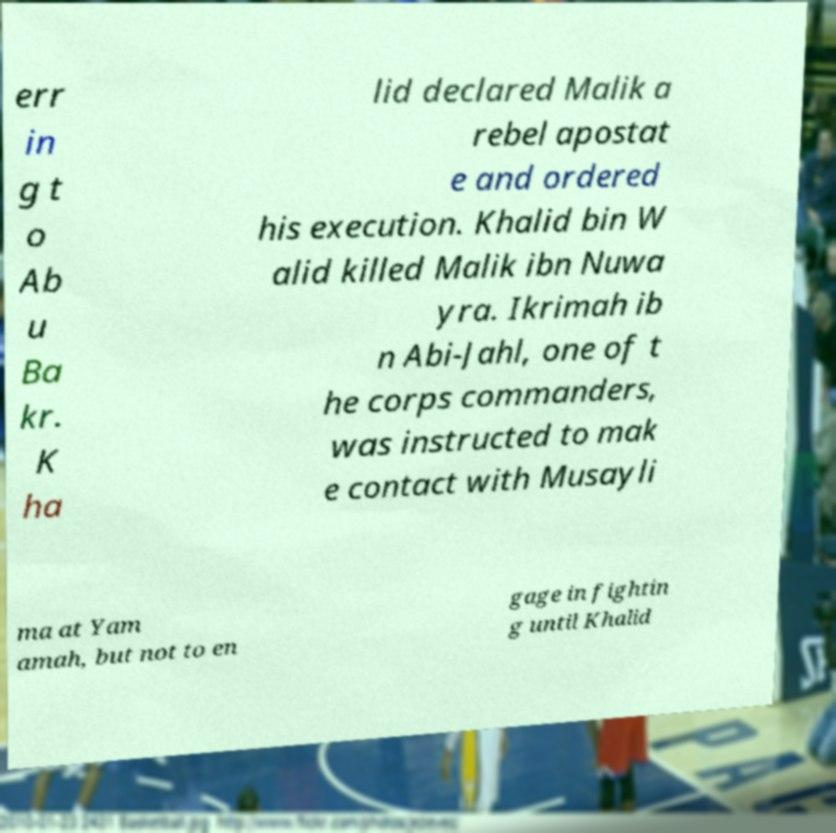Could you assist in decoding the text presented in this image and type it out clearly? err in g t o Ab u Ba kr. K ha lid declared Malik a rebel apostat e and ordered his execution. Khalid bin W alid killed Malik ibn Nuwa yra. Ikrimah ib n Abi-Jahl, one of t he corps commanders, was instructed to mak e contact with Musayli ma at Yam amah, but not to en gage in fightin g until Khalid 